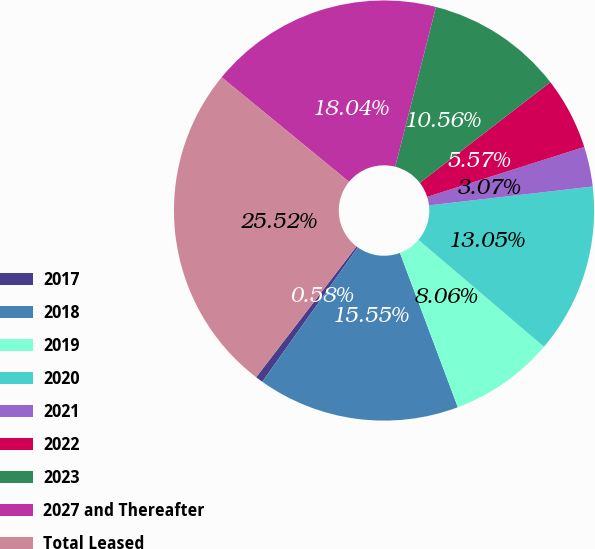<chart> <loc_0><loc_0><loc_500><loc_500><pie_chart><fcel>2017<fcel>2018<fcel>2019<fcel>2020<fcel>2021<fcel>2022<fcel>2023<fcel>2027 and Thereafter<fcel>Total Leased<nl><fcel>0.58%<fcel>15.55%<fcel>8.06%<fcel>13.05%<fcel>3.07%<fcel>5.57%<fcel>10.56%<fcel>18.04%<fcel>25.52%<nl></chart> 